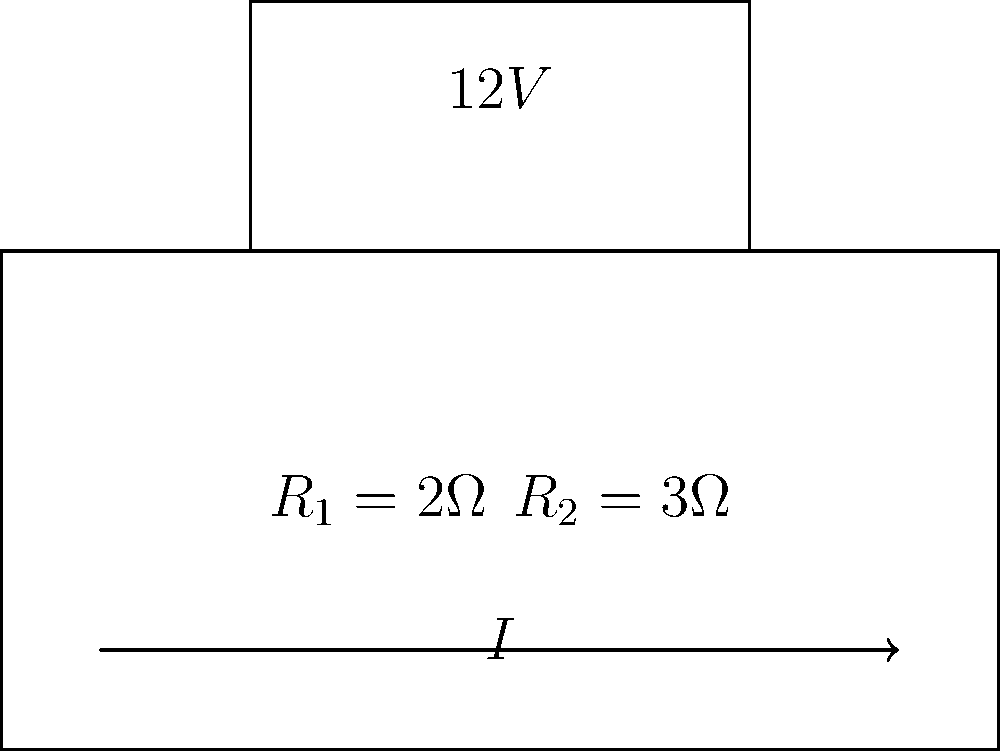In the circuit shown, a 12V battery is connected in series with two resistors, $R_1 = 2\Omega$ and $R_2 = 3\Omega$. What is the voltage drop across $R_2$? To solve this problem, we'll follow these steps:

1. Calculate the total resistance in the circuit:
   $R_{total} = R_1 + R_2 = 2\Omega + 3\Omega = 5\Omega$

2. Use Ohm's Law to find the current in the circuit:
   $I = \frac{V}{R_{total}} = \frac{12V}{5\Omega} = 2.4A$

3. Calculate the voltage drop across $R_2$ using Ohm's Law:
   $V_{R2} = I \times R_2 = 2.4A \times 3\Omega = 7.2V$

Therefore, the voltage drop across $R_2$ is 7.2V.
Answer: 7.2V 